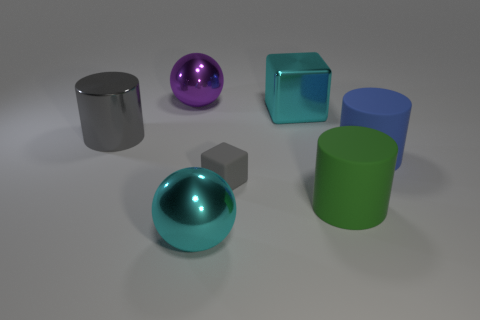How many other large blocks are the same color as the large cube?
Provide a short and direct response. 0. There is a green matte thing that is the same size as the shiny cylinder; what shape is it?
Keep it short and to the point. Cylinder. Is there a purple metallic sphere that has the same size as the gray metal cylinder?
Offer a very short reply. Yes. What material is the blue cylinder that is the same size as the cyan block?
Make the answer very short. Rubber. How big is the block behind the blue rubber cylinder to the right of the cyan cube?
Your answer should be very brief. Large. There is a cylinder left of the green thing; does it have the same size as the big blue matte cylinder?
Your answer should be very brief. Yes. Is the number of large gray metal cylinders behind the gray shiny cylinder greater than the number of blue cylinders in front of the green thing?
Your answer should be compact. No. The metallic thing that is both in front of the large cyan block and behind the blue rubber thing has what shape?
Your answer should be compact. Cylinder. The large cyan thing that is behind the blue matte object has what shape?
Keep it short and to the point. Cube. There is a purple metallic object that is to the left of the large matte thing behind the gray object on the right side of the purple metal sphere; how big is it?
Offer a very short reply. Large. 